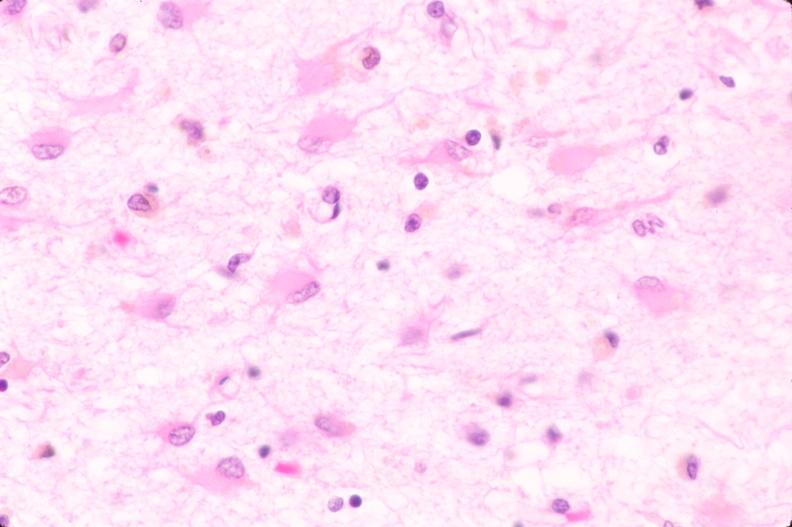does this image show brain, infarct due to ruptured saccular aneurysm and thrombosis of right middle cerebral artery, plasmacytic astrocytes?
Answer the question using a single word or phrase. Yes 